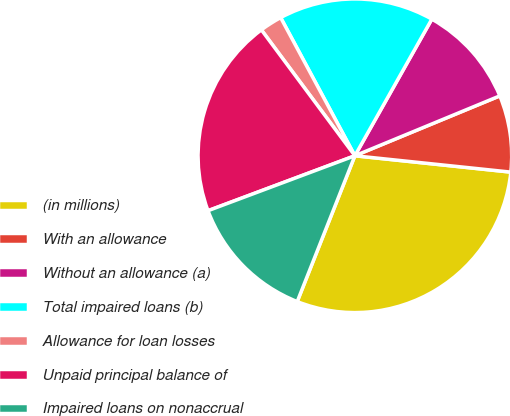Convert chart. <chart><loc_0><loc_0><loc_500><loc_500><pie_chart><fcel>(in millions)<fcel>With an allowance<fcel>Without an allowance (a)<fcel>Total impaired loans (b)<fcel>Allowance for loan losses<fcel>Unpaid principal balance of<fcel>Impaired loans on nonaccrual<nl><fcel>29.33%<fcel>7.9%<fcel>10.6%<fcel>16.01%<fcel>2.32%<fcel>20.53%<fcel>13.31%<nl></chart> 